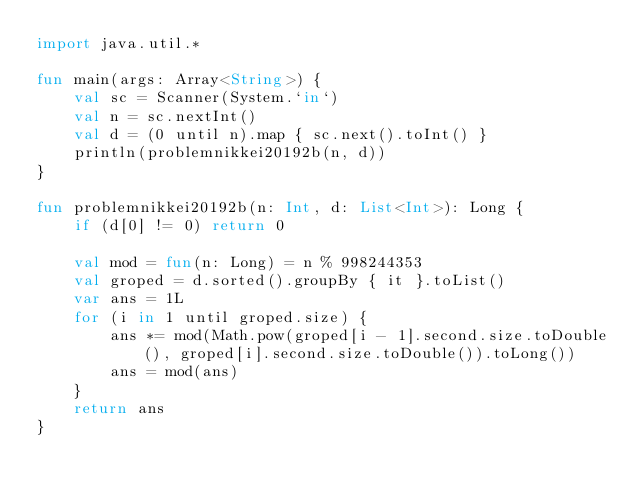<code> <loc_0><loc_0><loc_500><loc_500><_Kotlin_>import java.util.*

fun main(args: Array<String>) {
    val sc = Scanner(System.`in`)
    val n = sc.nextInt()
    val d = (0 until n).map { sc.next().toInt() }
    println(problemnikkei20192b(n, d))
}

fun problemnikkei20192b(n: Int, d: List<Int>): Long {
    if (d[0] != 0) return 0

    val mod = fun(n: Long) = n % 998244353
    val groped = d.sorted().groupBy { it }.toList()
    var ans = 1L
    for (i in 1 until groped.size) {
        ans *= mod(Math.pow(groped[i - 1].second.size.toDouble(), groped[i].second.size.toDouble()).toLong())
        ans = mod(ans)
    }
    return ans
}</code> 